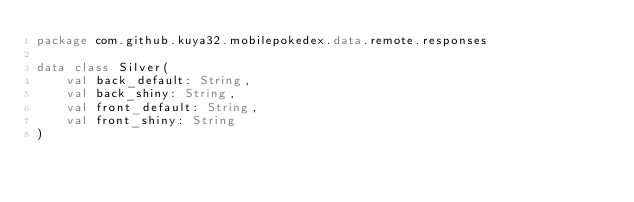<code> <loc_0><loc_0><loc_500><loc_500><_Kotlin_>package com.github.kuya32.mobilepokedex.data.remote.responses

data class Silver(
    val back_default: String,
    val back_shiny: String,
    val front_default: String,
    val front_shiny: String
)</code> 